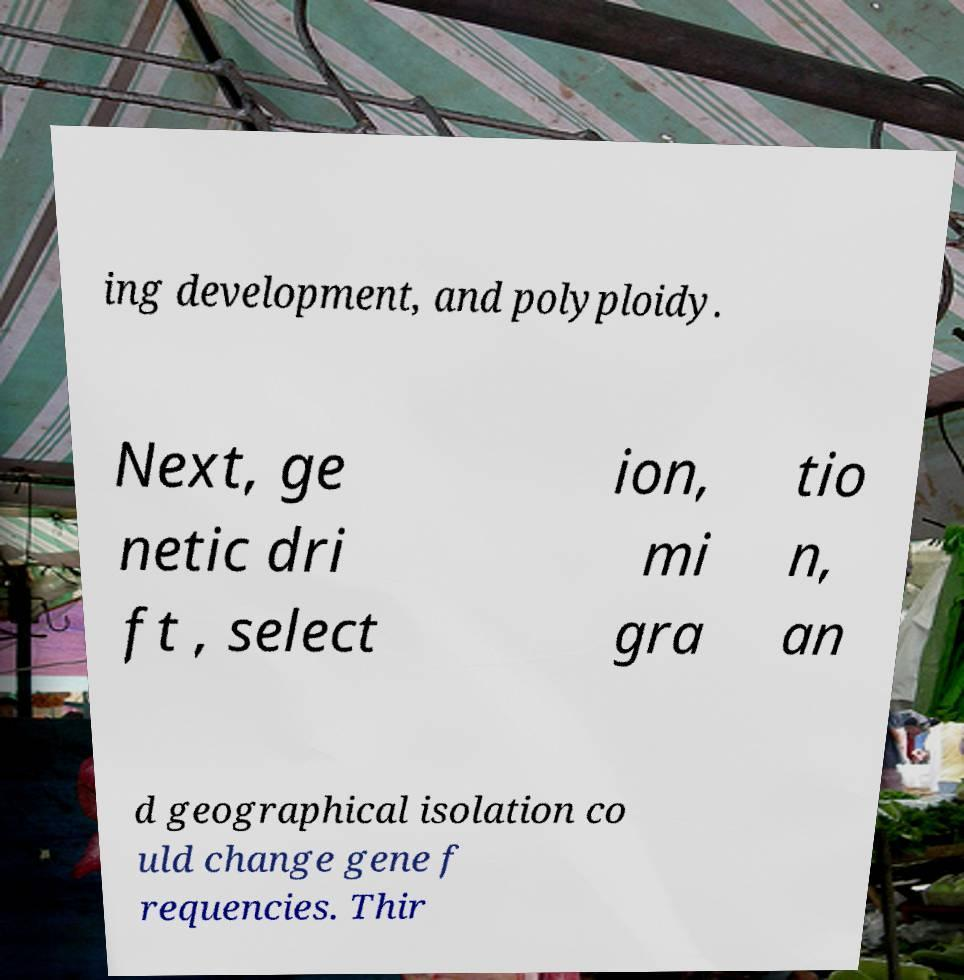Please identify and transcribe the text found in this image. ing development, and polyploidy. Next, ge netic dri ft , select ion, mi gra tio n, an d geographical isolation co uld change gene f requencies. Thir 